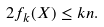<formula> <loc_0><loc_0><loc_500><loc_500>2 f _ { k } ( X ) \leq k n .</formula> 